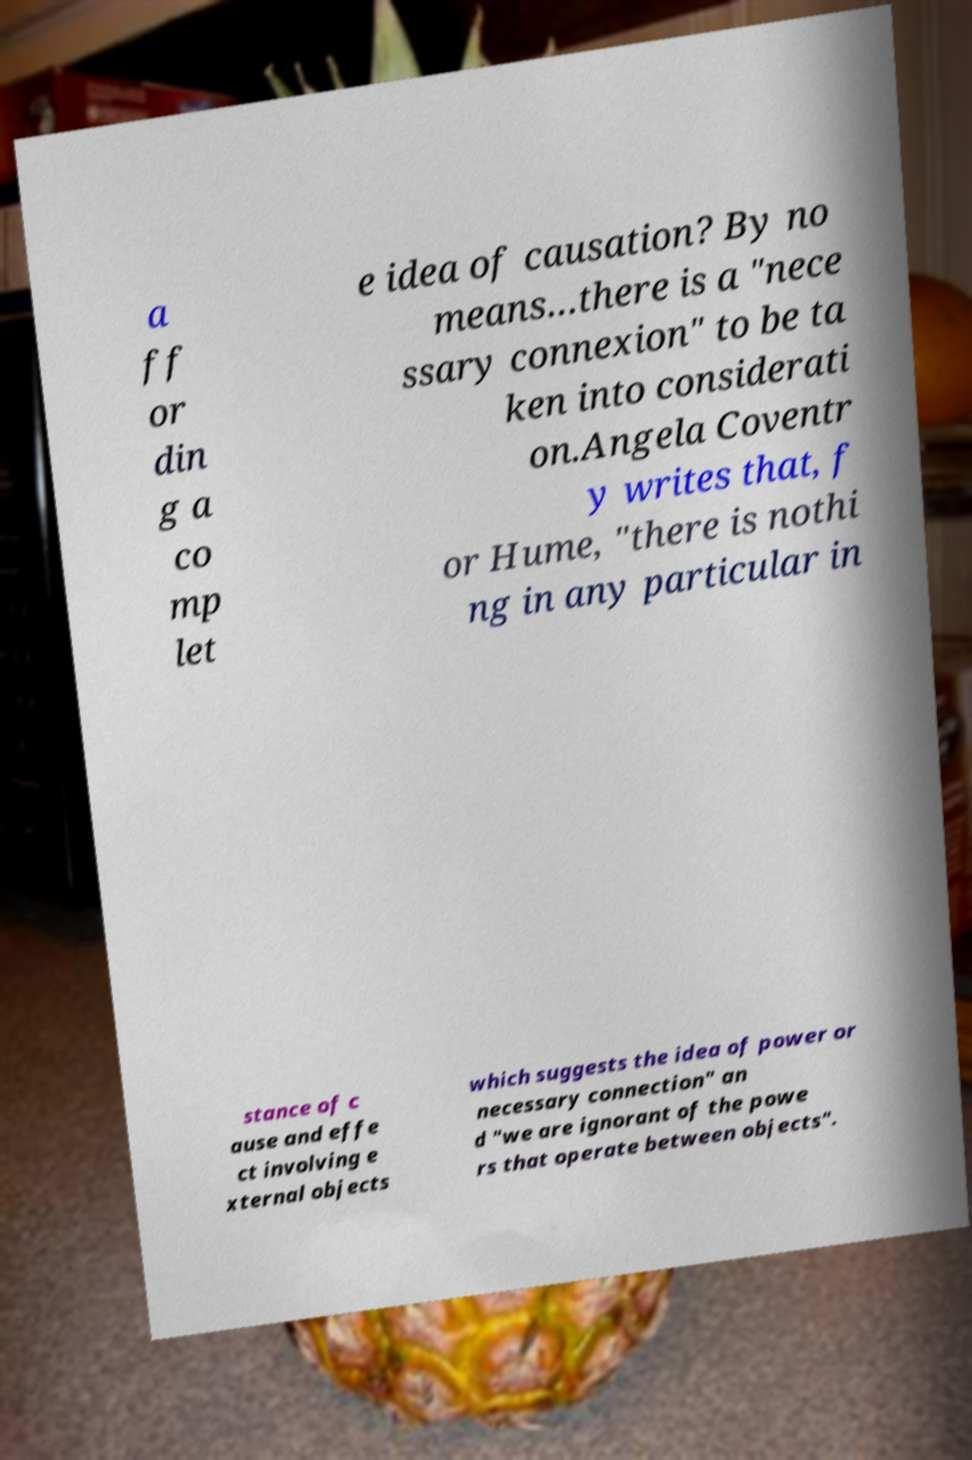Please read and relay the text visible in this image. What does it say? a ff or din g a co mp let e idea of causation? By no means…there is a "nece ssary connexion" to be ta ken into considerati on.Angela Coventr y writes that, f or Hume, "there is nothi ng in any particular in stance of c ause and effe ct involving e xternal objects which suggests the idea of power or necessary connection" an d "we are ignorant of the powe rs that operate between objects". 